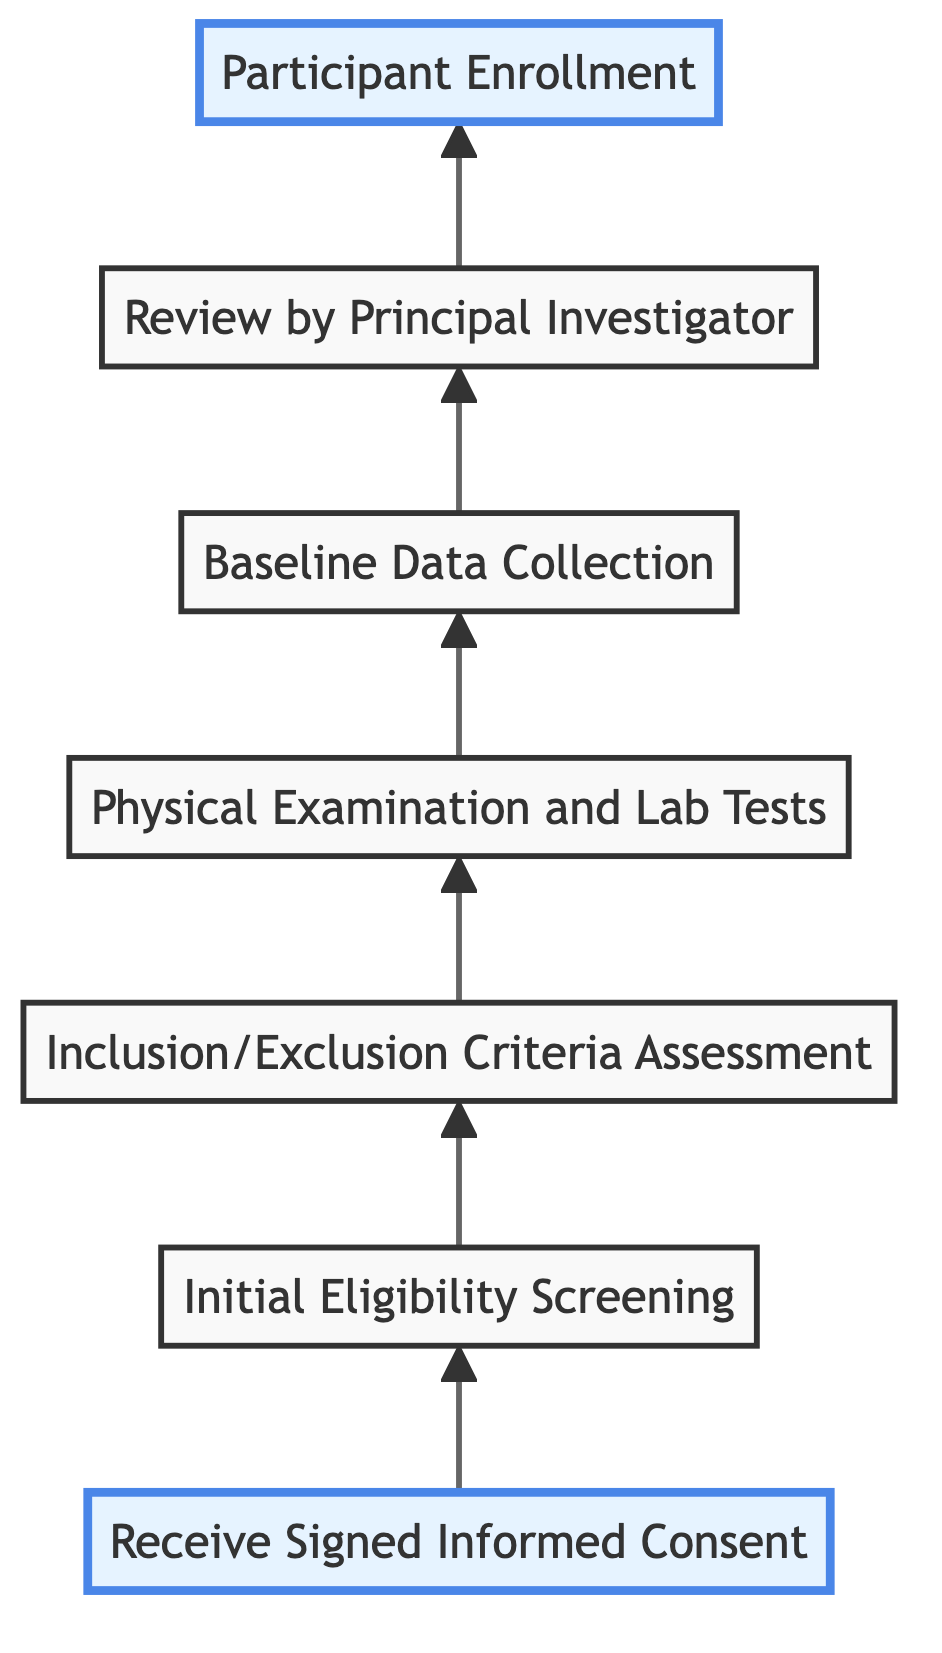what is the first step in the process? The diagram shows that the first step is labeled "Receive Signed Informed Consent," indicating that this is the initial action taken in the screening and enrollment process.
Answer: Receive Signed Informed Consent how many steps are there in total? By counting the distinct labeled steps, it is noted that there are seven steps outlined in the flowchart.
Answer: 7 what follows "Physical Examination and Lab Tests"? Looking at the flowchart, the step that follows "Physical Examination and Lab Tests" is "Baseline Data Collection," which indicates the sequence of steps in the enrollment process.
Answer: Baseline Data Collection which step is highlighted in the diagram? The highlighted steps in the flowchart are "Receive Signed Informed Consent" and "Participant Enrollment," denoting significant points in the process.
Answer: Receive Signed Informed Consent, Participant Enrollment what is the last step of the enrollment process? The final step, as indicated at the top of the flowchart, is "Participant Enrollment," which is the concluding action in the screening and enrollment procedure.
Answer: Participant Enrollment describe the relationship between "Inclusion/Exclusion Criteria Assessment" and "Review by Principal Investigator." The flowchart indicates that "Inclusion/Exclusion Criteria Assessment" directly precedes "Review by Principal Investigator," showing that the assessment is necessary before the review takes place.
Answer: Assessment precedes review what step involves collecting data on skin conditions? The step that involves collecting data on skin conditions is "Baseline Data Collection," as indicated in the sequence of the flowchart.
Answer: Baseline Data Collection which step leads to "Participant Enrollment"? The step that directly leads to "Participant Enrollment" is "Review by Principal Investigator," as the decision to enroll participants is made after this review.
Answer: Review by Principal Investigator 